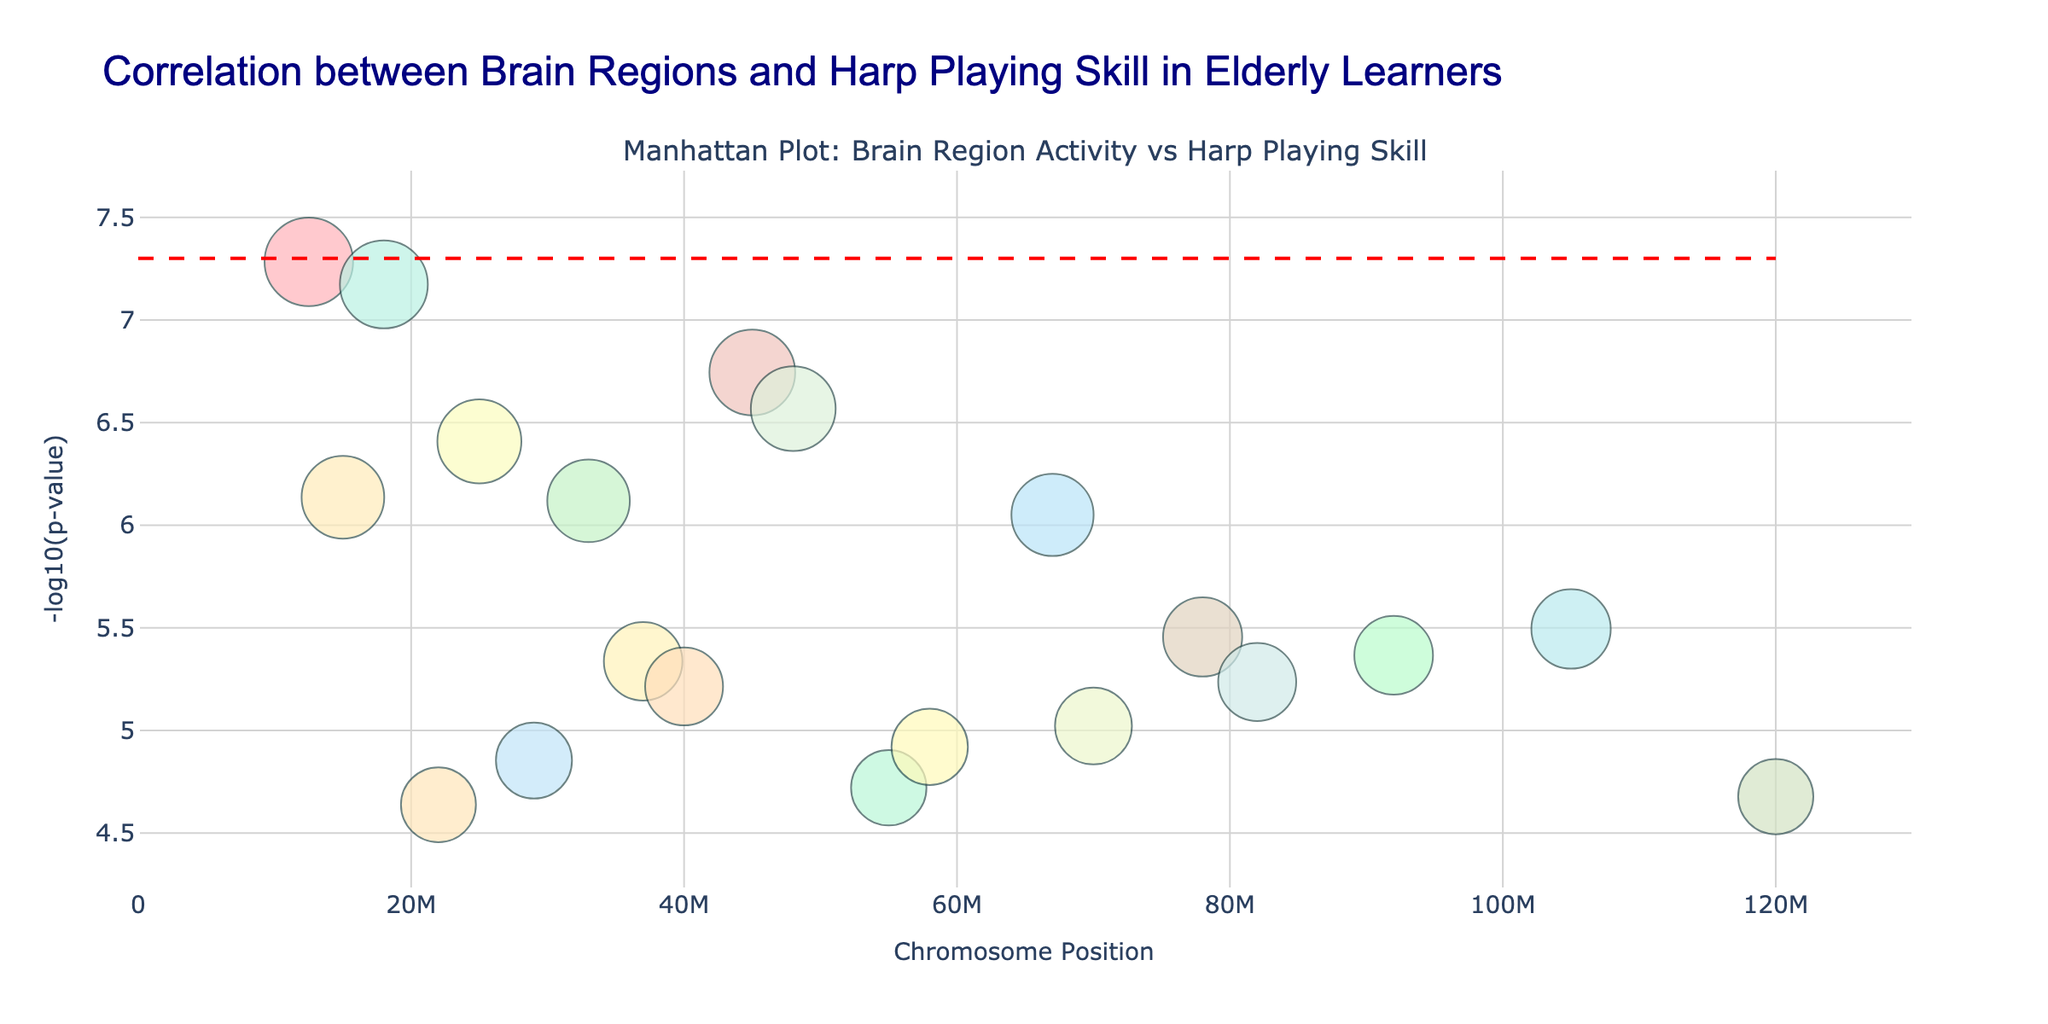What is the title of the figure? The title is visible at the top of the figure, indicating what the plot represents.
Answer: Correlation between Brain Regions and Harp Playing Skill in Elderly Learners What does the y-axis represent? The text on the y-axis provides information about what is being measured. It shows "-log10(p-value)" indicating the logarithmic transformation of p-values.
Answer: -log10(p-value) Which brain region has the most significant p-value? By observing the y-axis value for each data point, the highest value on the y-axis corresponds to the smallest p-value. The text associated with the highest marker provides the brain region.
Answer: Primary Motor Cortex How many brain regions have a p-value smaller than the threshold line? The threshold line represents a p-value cutoff. Count the number of points above this line to determine how many regions are significant.
Answer: 3 Which chromosome position has the highest -log10(p-value)? The highest value on the y-axis represents the maximum -log10(p-value). The x-axis value at this point indicates the chromosome position.
Answer: 12500000 What is the color scheme used for different chromosomes? The color distribution among the points indicates how chromosomes are differentiated. The unique colors are assigned cyclically to various chromosomes. Colors in use include shades of red, green, blue, yellow, and orange.
Answer: Shades of red, green, blue, yellow, orange Compare the -log10(p-value) of Broca's Area and Auditory Cortex. Which one is more significant? Locate the y-axis values for Broca's Area and Auditory Cortex on the plot. The higher y-value indicates a more significant result.
Answer: Broca's Area Which brain region on chromosome 13 has a significant correlation with harp playing skill levels? By checking the chromosome positions, identify the brain region listed under chromosome 13 on the plot.
Answer: Hippocampus Considering the brain regions listed in the plot, which one has the highest -log10(p-value) among those with values between 6 and 7? Determine which points fall within the y-axis range of 6 to 7 and find the highest point within this range. Identify the corresponding brain region from the text markers.
Answer: Premotor Cortex 